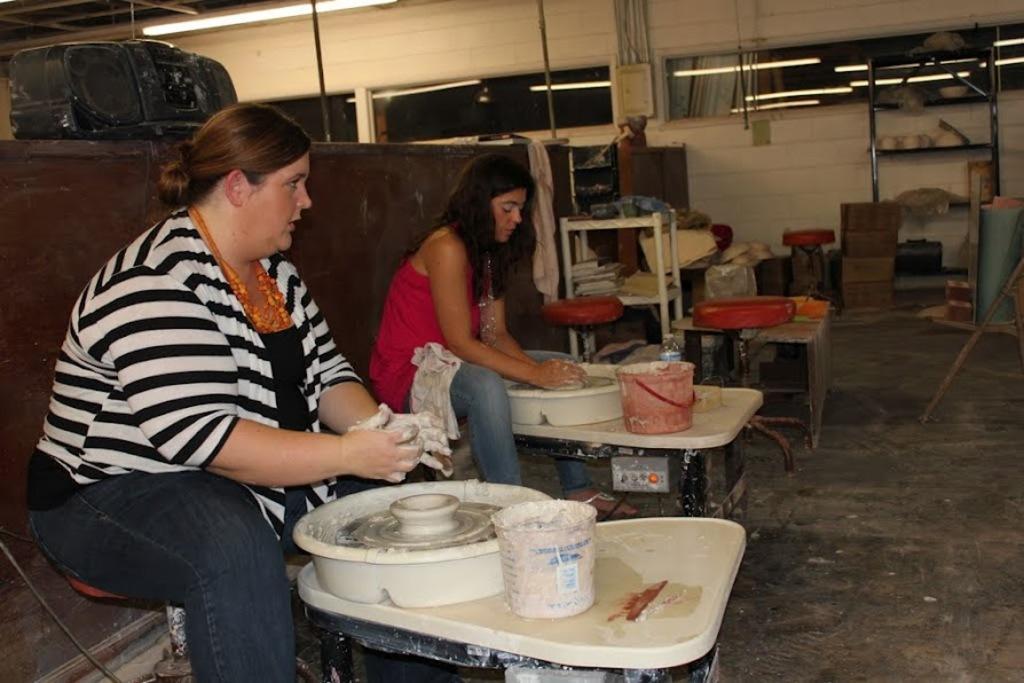Could you give a brief overview of what you see in this image? As we can see in the image there is a wall, two people sitting over here and in front of them there is a table. On table there is a bucket and tray. 